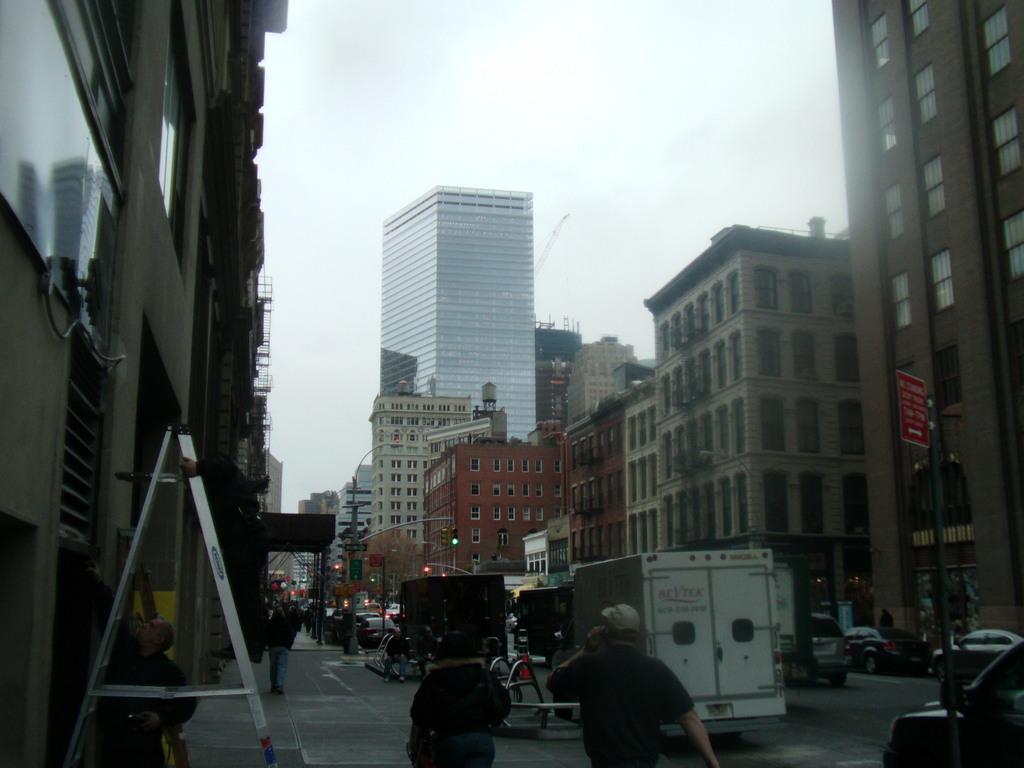How would you summarize this image in a sentence or two? In this image we can see buildings, street poles, traffic lights, motor vehicles and persons on the road. 